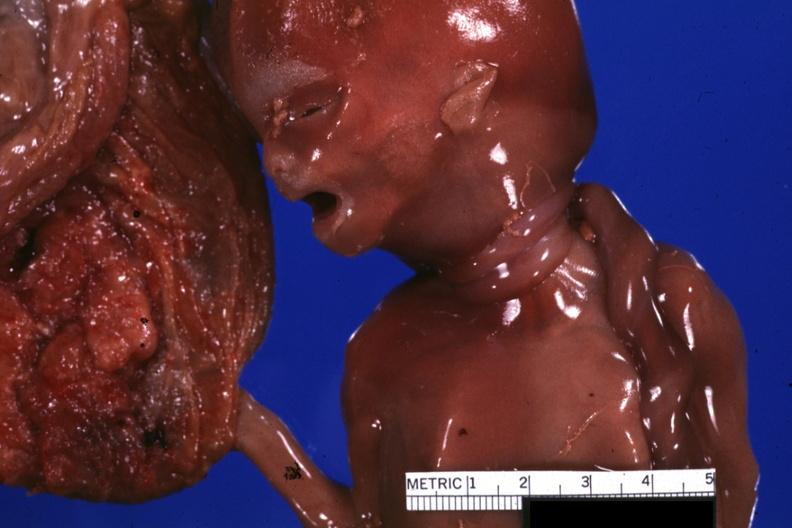what does this image show?
Answer the question using a single word or phrase. Close-up of two loops of umbilical cord around neck 